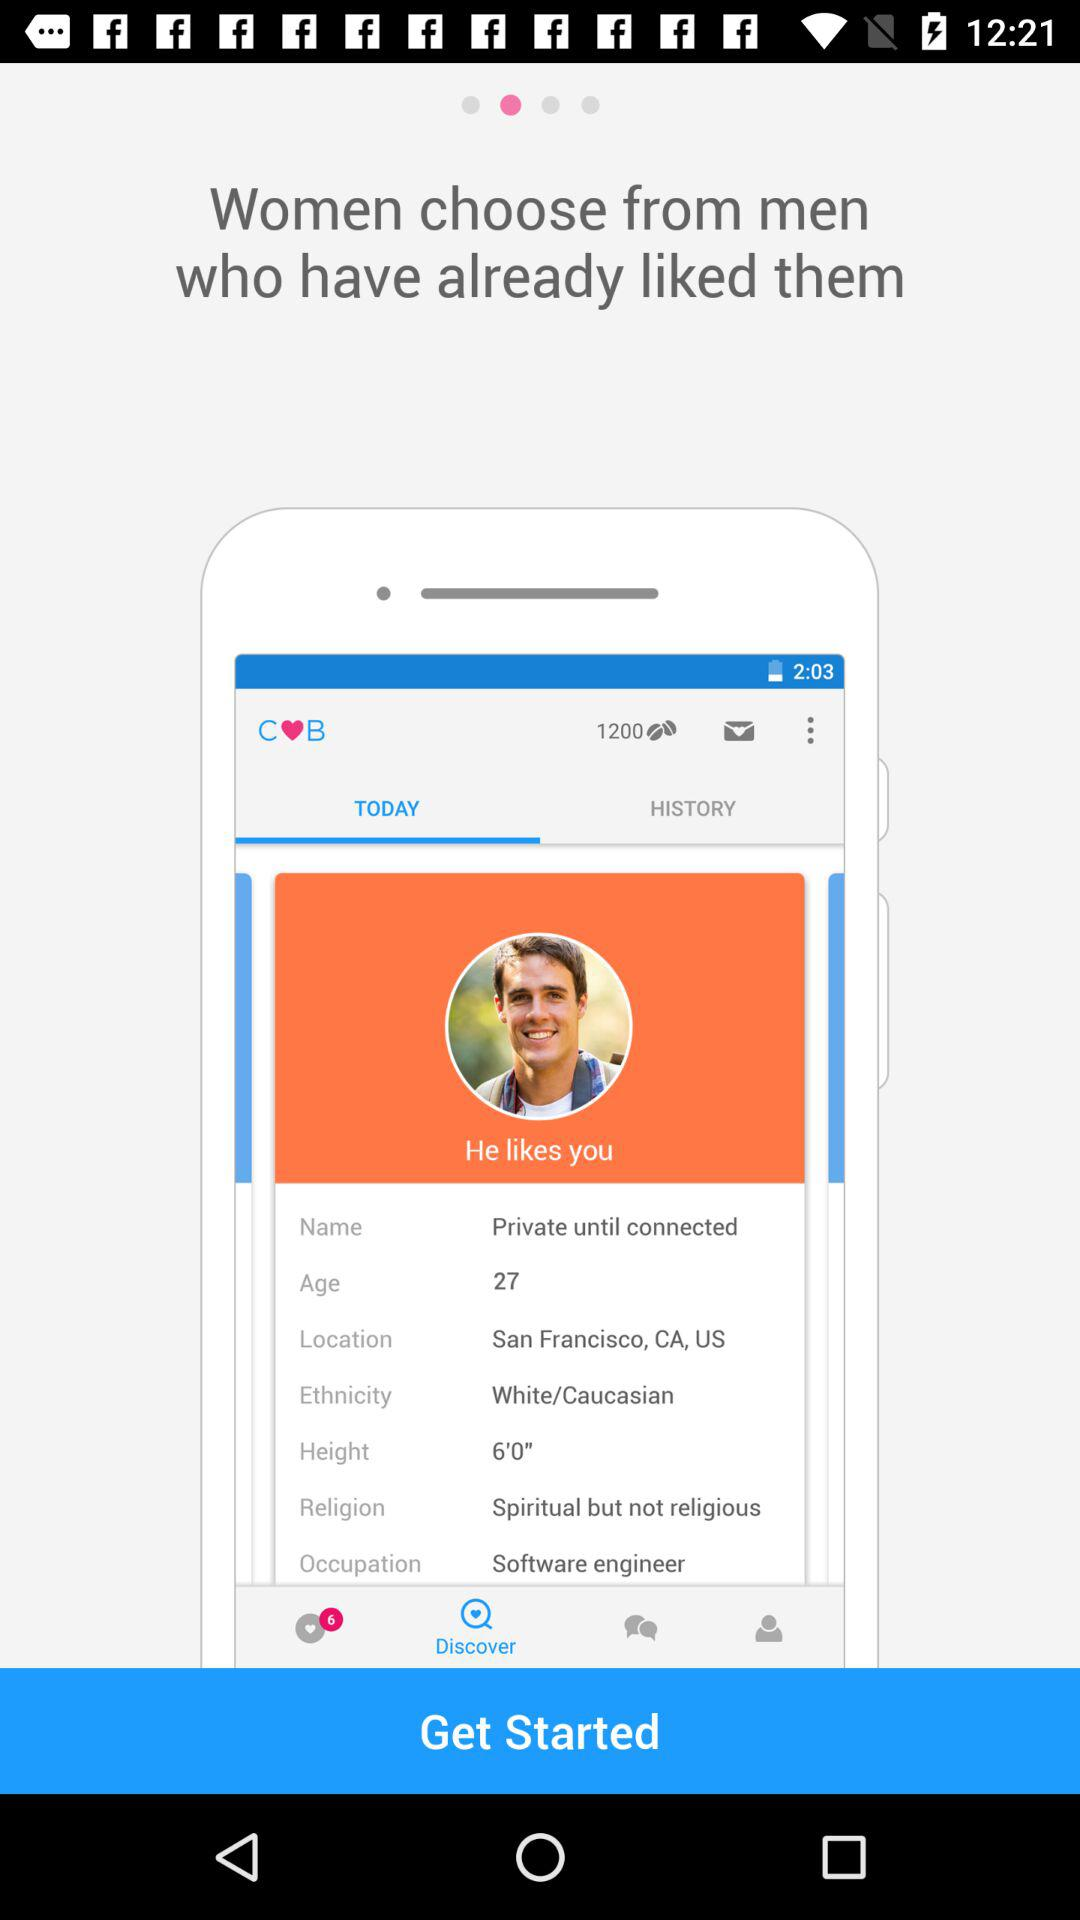What is the location given on the screen? The location given on the screen is San Francisco, CA, US. 